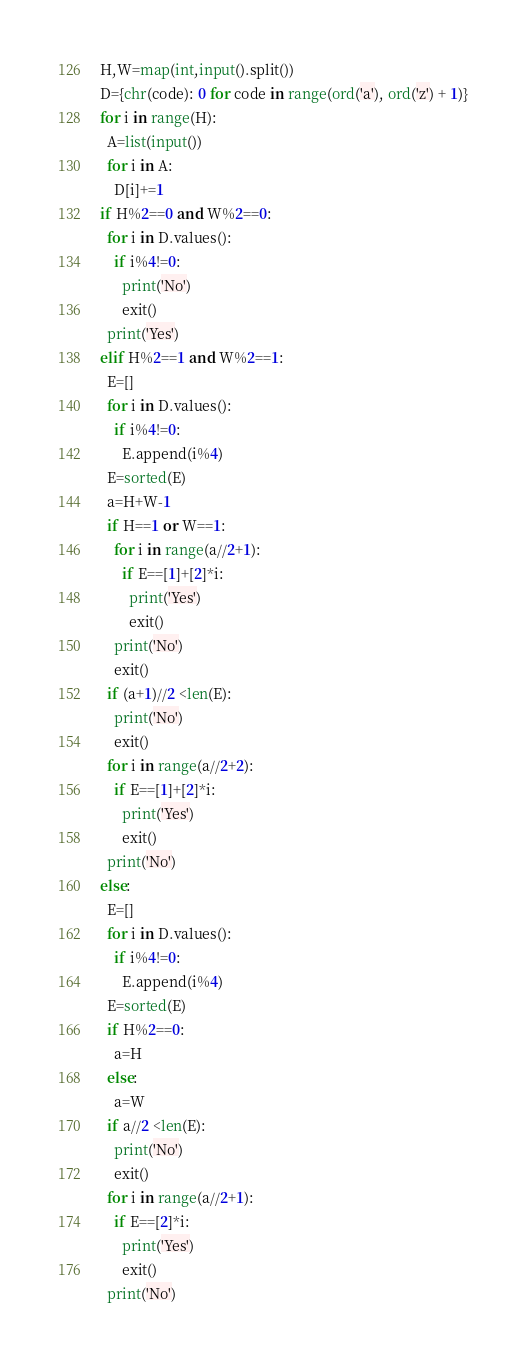<code> <loc_0><loc_0><loc_500><loc_500><_Python_>H,W=map(int,input().split())
D={chr(code): 0 for code in range(ord('a'), ord('z') + 1)}
for i in range(H):
  A=list(input())
  for i in A:
    D[i]+=1
if H%2==0 and W%2==0:
  for i in D.values():
    if i%4!=0:
      print('No')
      exit()
  print('Yes')
elif H%2==1 and W%2==1:
  E=[]
  for i in D.values():
    if i%4!=0:
      E.append(i%4)
  E=sorted(E)
  a=H+W-1
  if H==1 or W==1:
    for i in range(a//2+1):
      if E==[1]+[2]*i:
        print('Yes')
        exit()
    print('No')
    exit()    
  if (a+1)//2 <len(E):
    print('No')
    exit()
  for i in range(a//2+2):
    if E==[1]+[2]*i:
      print('Yes')
      exit()
  print('No')
else:
  E=[]
  for i in D.values():
    if i%4!=0:
      E.append(i%4)
  E=sorted(E)
  if H%2==0:
    a=H
  else:
    a=W
  if a//2 <len(E):
    print('No')
    exit()
  for i in range(a//2+1):
    if E==[2]*i:
      print('Yes')
      exit()
  print('No')
</code> 